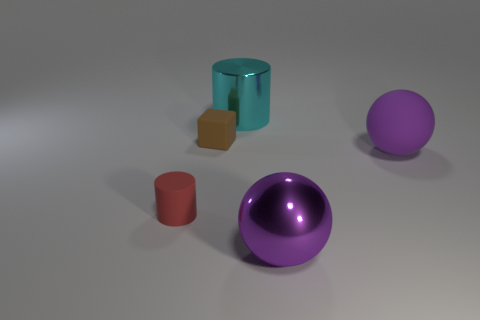Add 3 tiny matte cylinders. How many objects exist? 8 Subtract all cylinders. How many objects are left? 3 Add 2 small matte things. How many small matte things are left? 4 Add 4 large brown cubes. How many large brown cubes exist? 4 Subtract 0 blue cylinders. How many objects are left? 5 Subtract all small brown objects. Subtract all shiny cylinders. How many objects are left? 3 